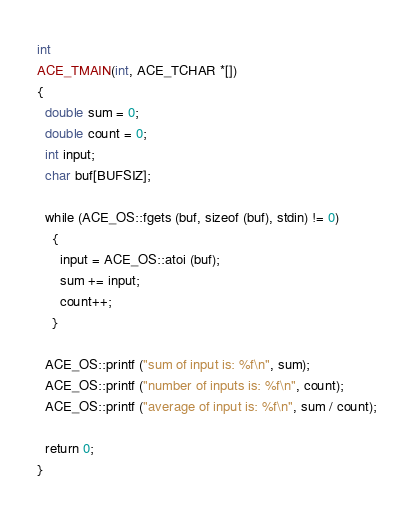<code> <loc_0><loc_0><loc_500><loc_500><_C++_>int
ACE_TMAIN(int, ACE_TCHAR *[])
{
  double sum = 0;
  double count = 0;
  int input;
  char buf[BUFSIZ];

  while (ACE_OS::fgets (buf, sizeof (buf), stdin) != 0)
    {
      input = ACE_OS::atoi (buf);
      sum += input;
      count++;
    }

  ACE_OS::printf ("sum of input is: %f\n", sum);
  ACE_OS::printf ("number of inputs is: %f\n", count);
  ACE_OS::printf ("average of input is: %f\n", sum / count);

  return 0;
}
</code> 